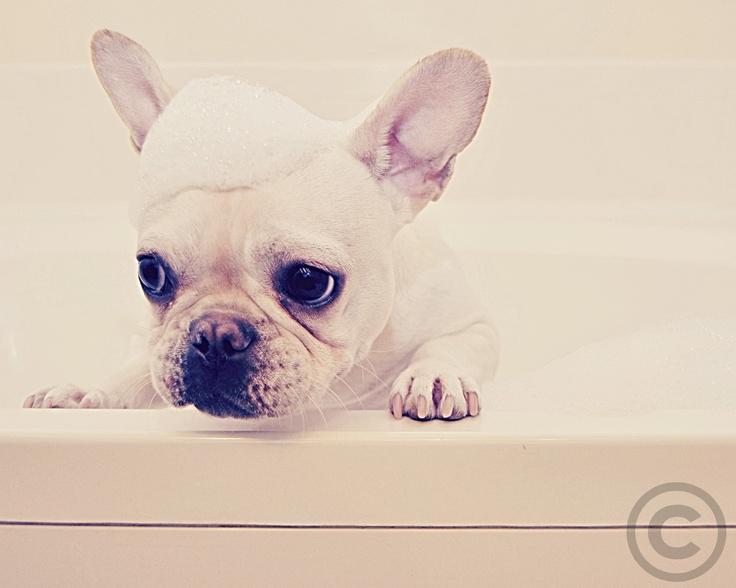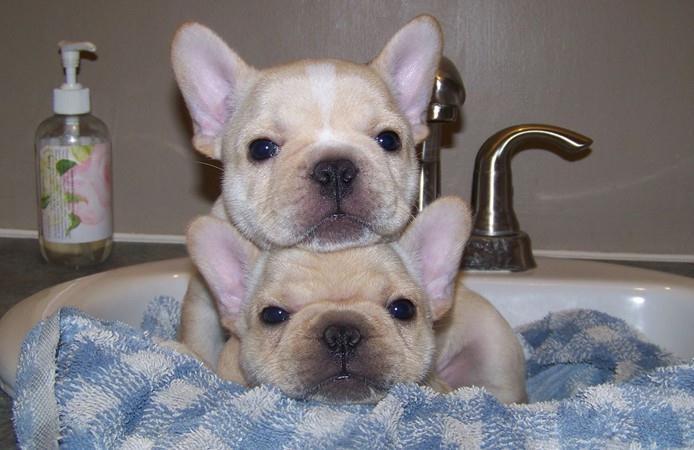The first image is the image on the left, the second image is the image on the right. Analyze the images presented: Is the assertion "In one pair, three French bulldogs are in the bathtub, while in the other pair one French bulldog is in the bathtub and two others are outside the tub looking over the side." valid? Answer yes or no. No. The first image is the image on the left, the second image is the image on the right. Assess this claim about the two images: "In the left image, one white bulldog is alone in a white tub and has its front paws on the rim of the tub.". Correct or not? Answer yes or no. Yes. 